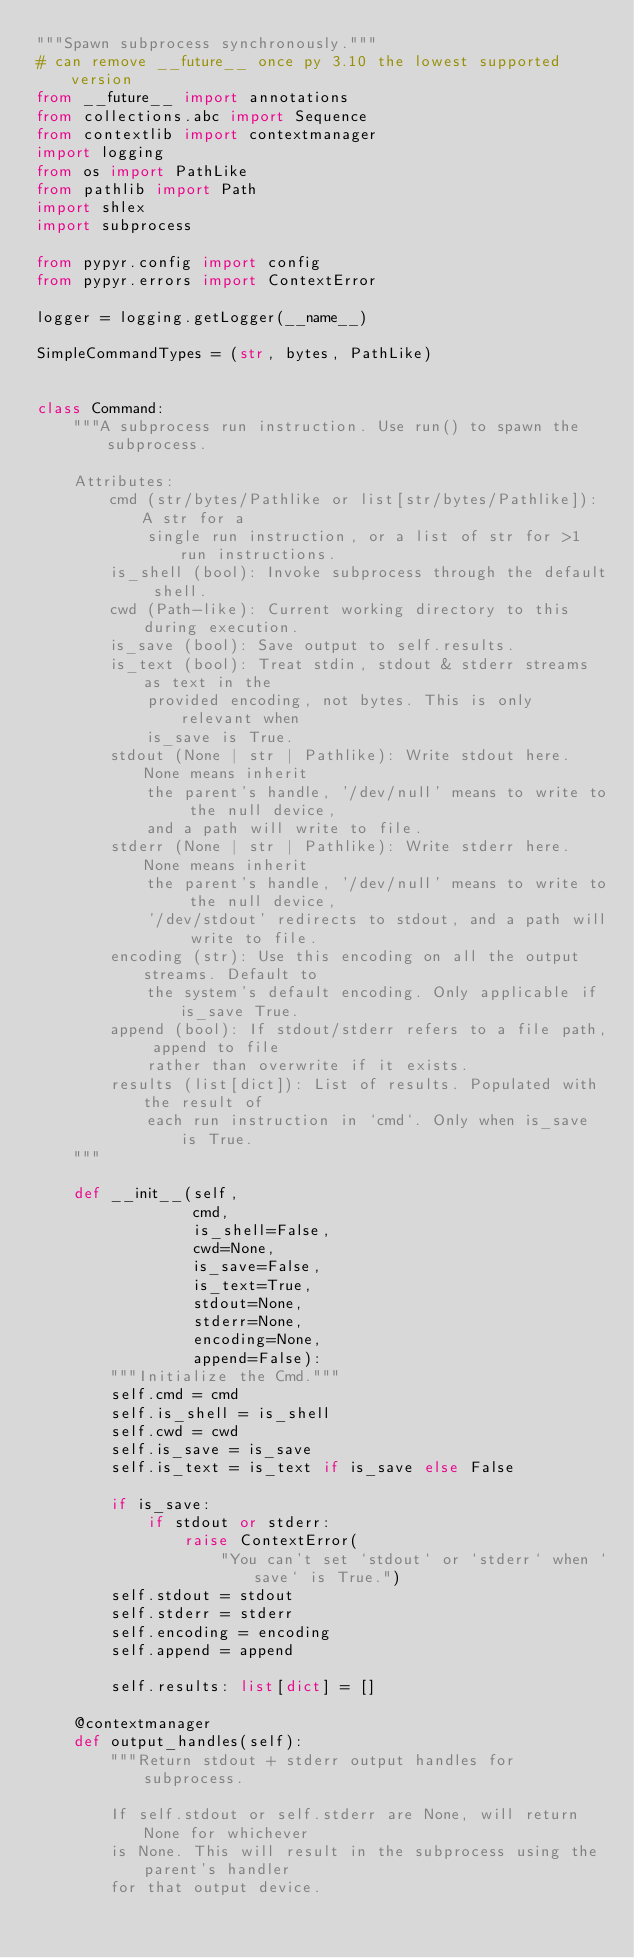Convert code to text. <code><loc_0><loc_0><loc_500><loc_500><_Python_>"""Spawn subprocess synchronously."""
# can remove __future__ once py 3.10 the lowest supported version
from __future__ import annotations
from collections.abc import Sequence
from contextlib import contextmanager
import logging
from os import PathLike
from pathlib import Path
import shlex
import subprocess

from pypyr.config import config
from pypyr.errors import ContextError

logger = logging.getLogger(__name__)

SimpleCommandTypes = (str, bytes, PathLike)


class Command:
    """A subprocess run instruction. Use run() to spawn the subprocess.

    Attributes:
        cmd (str/bytes/Pathlike or list[str/bytes/Pathlike]): A str for a
            single run instruction, or a list of str for >1 run instructions.
        is_shell (bool): Invoke subprocess through the default shell.
        cwd (Path-like): Current working directory to this during execution.
        is_save (bool): Save output to self.results.
        is_text (bool): Treat stdin, stdout & stderr streams as text in the
            provided encoding, not bytes. This is only relevant when
            is_save is True.
        stdout (None | str | Pathlike): Write stdout here. None means inherit
            the parent's handle, '/dev/null' means to write to the null device,
            and a path will write to file.
        stderr (None | str | Pathlike): Write stderr here. None means inherit
            the parent's handle, '/dev/null' means to write to the null device,
            '/dev/stdout' redirects to stdout, and a path will write to file.
        encoding (str): Use this encoding on all the output streams. Default to
            the system's default encoding. Only applicable if is_save True.
        append (bool): If stdout/stderr refers to a file path, append to file
            rather than overwrite if it exists.
        results (list[dict]): List of results. Populated with the result of
            each run instruction in `cmd`. Only when is_save is True.
    """

    def __init__(self,
                 cmd,
                 is_shell=False,
                 cwd=None,
                 is_save=False,
                 is_text=True,
                 stdout=None,
                 stderr=None,
                 encoding=None,
                 append=False):
        """Initialize the Cmd."""
        self.cmd = cmd
        self.is_shell = is_shell
        self.cwd = cwd
        self.is_save = is_save
        self.is_text = is_text if is_save else False

        if is_save:
            if stdout or stderr:
                raise ContextError(
                    "You can't set `stdout` or `stderr` when `save` is True.")
        self.stdout = stdout
        self.stderr = stderr
        self.encoding = encoding
        self.append = append

        self.results: list[dict] = []

    @contextmanager
    def output_handles(self):
        """Return stdout + stderr output handles for subprocess.

        If self.stdout or self.stderr are None, will return None for whichever
        is None. This will result in the subprocess using the parent's handler
        for that output device.
</code> 